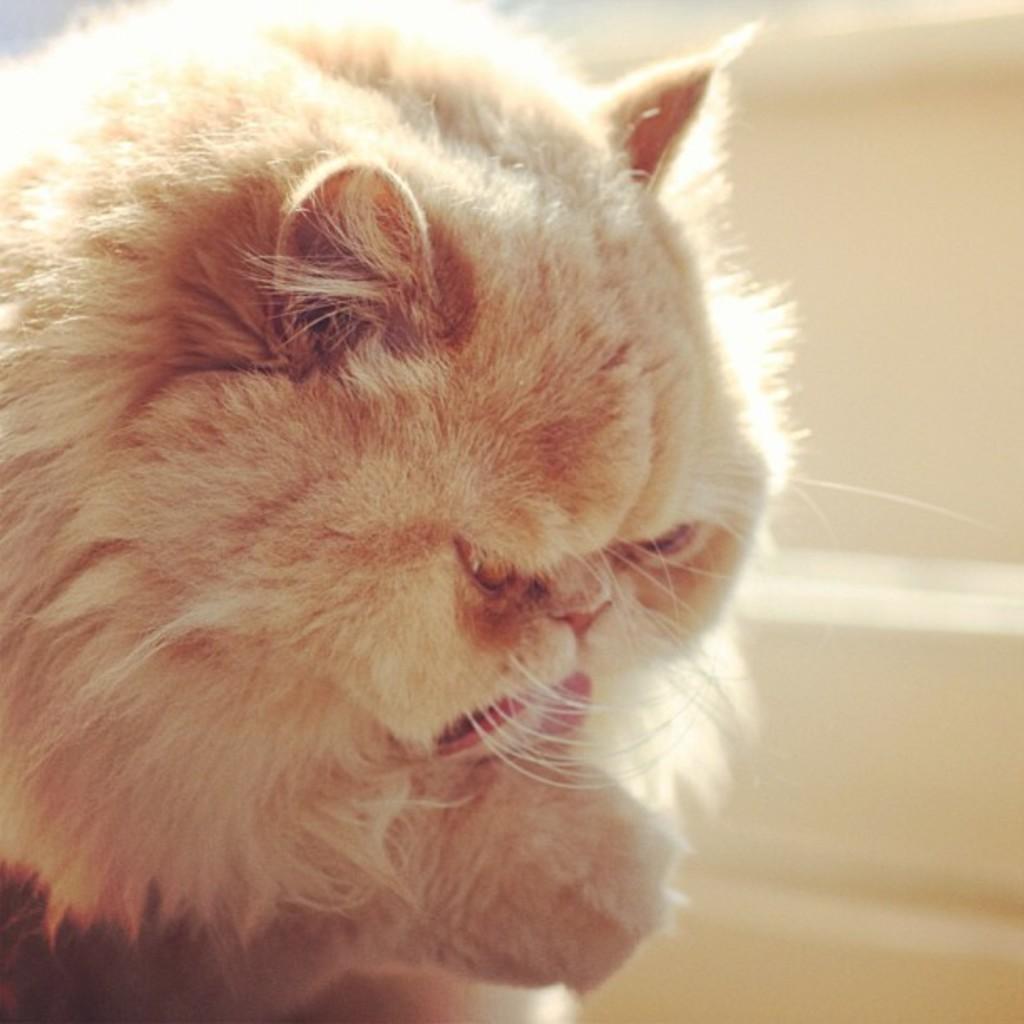Describe this image in one or two sentences. In this image we can see a cat. Behind the wall we can see the wall. 